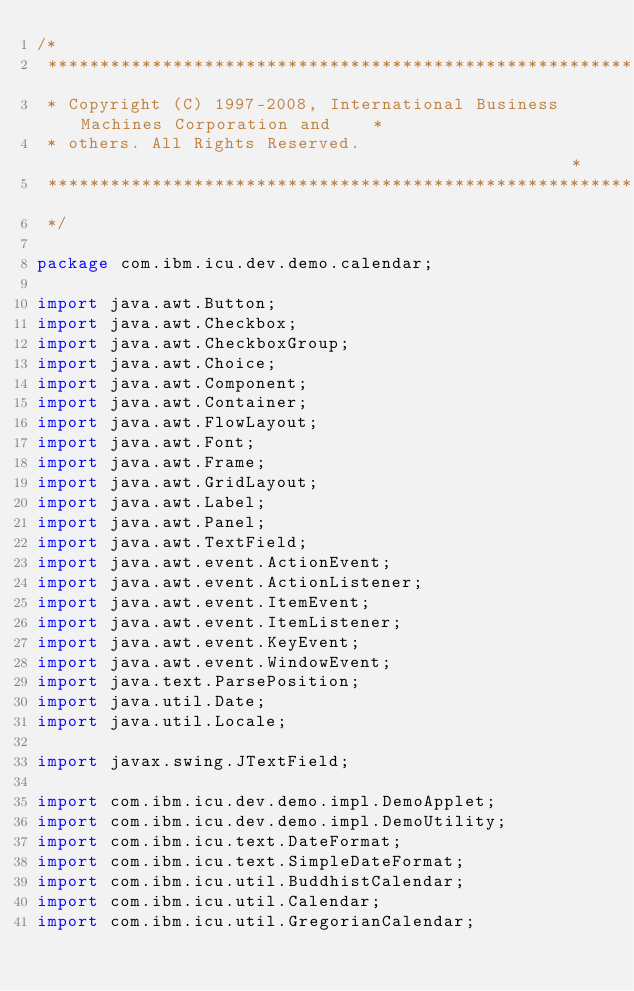<code> <loc_0><loc_0><loc_500><loc_500><_Java_>/*
 *******************************************************************************
 * Copyright (C) 1997-2008, International Business Machines Corporation and    *
 * others. All Rights Reserved.                                                *
 *******************************************************************************
 */

package com.ibm.icu.dev.demo.calendar;

import java.awt.Button;
import java.awt.Checkbox;
import java.awt.CheckboxGroup;
import java.awt.Choice;
import java.awt.Component;
import java.awt.Container;
import java.awt.FlowLayout;
import java.awt.Font;
import java.awt.Frame;
import java.awt.GridLayout;
import java.awt.Label;
import java.awt.Panel;
import java.awt.TextField;
import java.awt.event.ActionEvent;
import java.awt.event.ActionListener;
import java.awt.event.ItemEvent;
import java.awt.event.ItemListener;
import java.awt.event.KeyEvent;
import java.awt.event.WindowEvent;
import java.text.ParsePosition;
import java.util.Date;
import java.util.Locale;

import javax.swing.JTextField;

import com.ibm.icu.dev.demo.impl.DemoApplet;
import com.ibm.icu.dev.demo.impl.DemoUtility;
import com.ibm.icu.text.DateFormat;
import com.ibm.icu.text.SimpleDateFormat;
import com.ibm.icu.util.BuddhistCalendar;
import com.ibm.icu.util.Calendar;
import com.ibm.icu.util.GregorianCalendar;</code> 